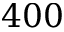Convert formula to latex. <formula><loc_0><loc_0><loc_500><loc_500>4 0 0</formula> 